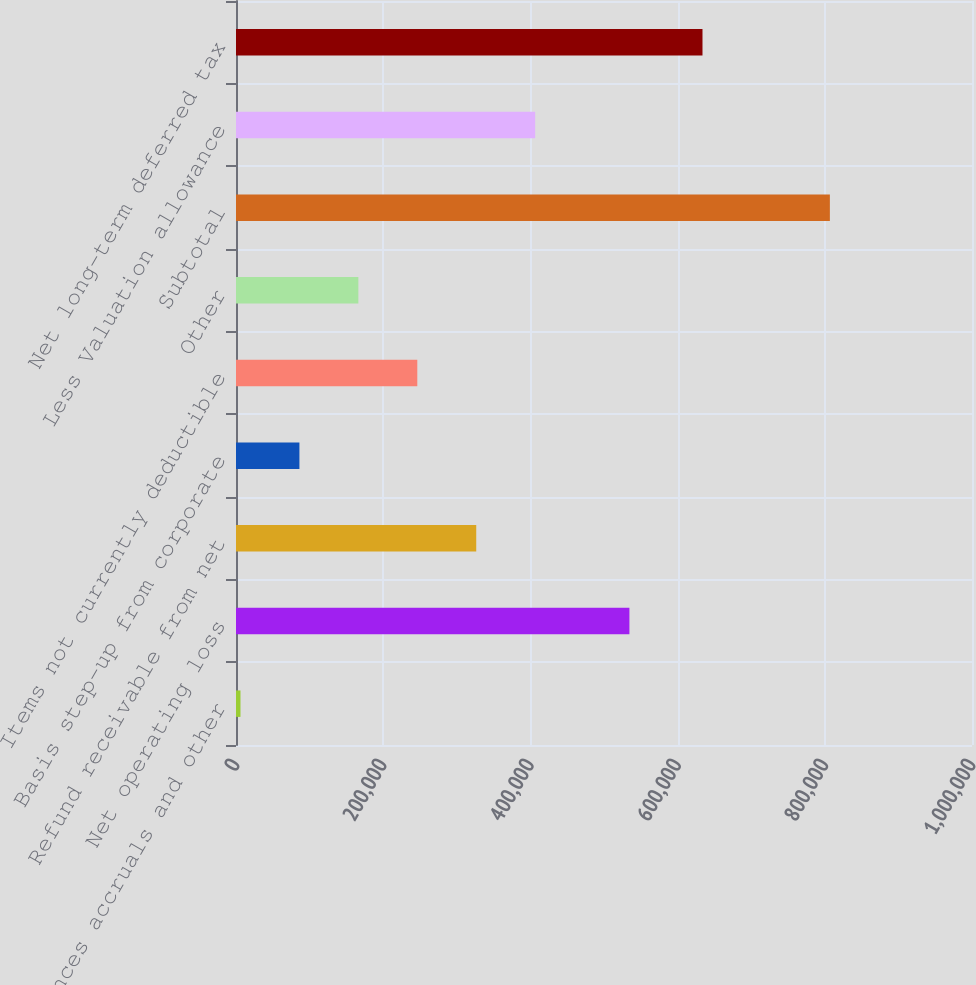<chart> <loc_0><loc_0><loc_500><loc_500><bar_chart><fcel>Allowances accruals and other<fcel>Net operating loss<fcel>Refund receivable from net<fcel>Basis step-up from corporate<fcel>Items not currently deductible<fcel>Other<fcel>Subtotal<fcel>Less Valuation allowance<fcel>Net long-term deferred tax<nl><fcel>6090<fcel>534529<fcel>326410<fcel>86170.1<fcel>246330<fcel>166250<fcel>806891<fcel>406490<fcel>633814<nl></chart> 